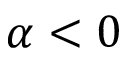<formula> <loc_0><loc_0><loc_500><loc_500>\alpha < 0</formula> 